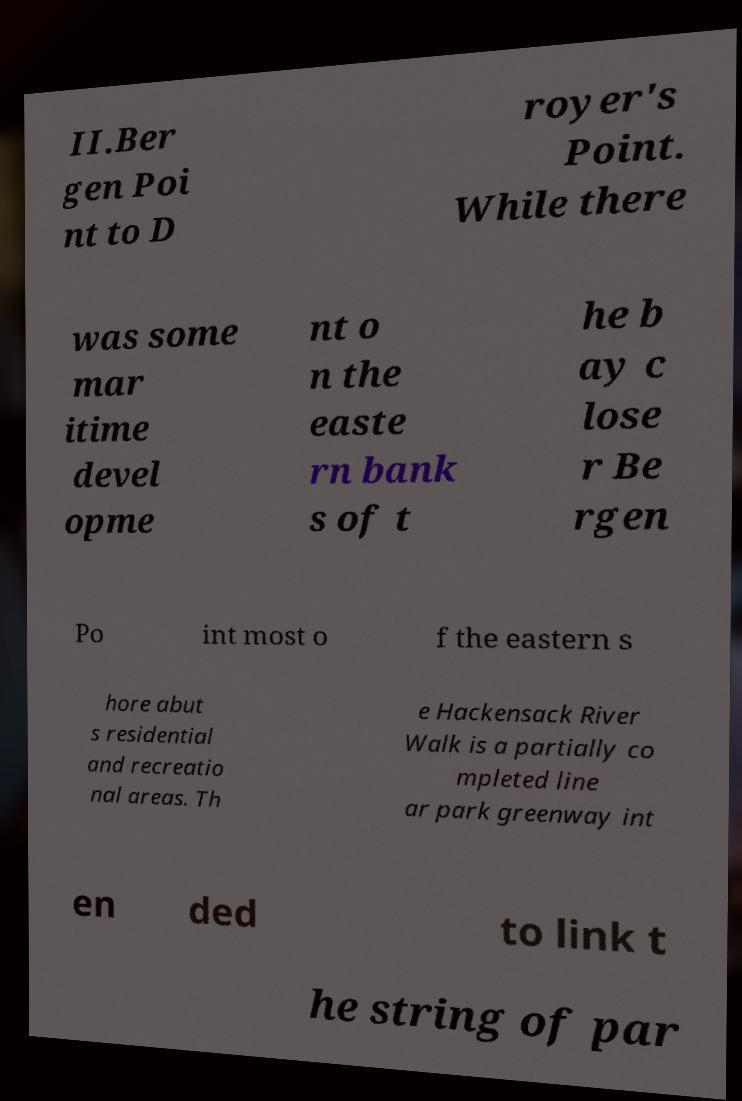What messages or text are displayed in this image? I need them in a readable, typed format. II.Ber gen Poi nt to D royer's Point. While there was some mar itime devel opme nt o n the easte rn bank s of t he b ay c lose r Be rgen Po int most o f the eastern s hore abut s residential and recreatio nal areas. Th e Hackensack River Walk is a partially co mpleted line ar park greenway int en ded to link t he string of par 